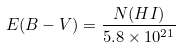<formula> <loc_0><loc_0><loc_500><loc_500>E ( B - V ) = \frac { N ( H I ) } { 5 . 8 \times 1 0 ^ { 2 1 } }</formula> 